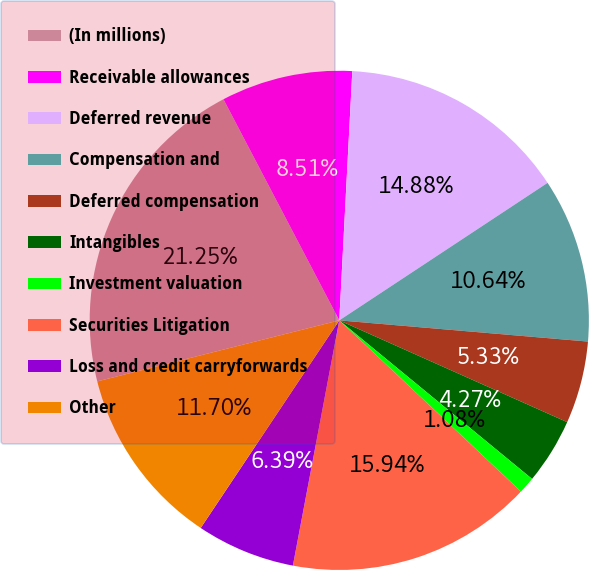Convert chart. <chart><loc_0><loc_0><loc_500><loc_500><pie_chart><fcel>(In millions)<fcel>Receivable allowances<fcel>Deferred revenue<fcel>Compensation and<fcel>Deferred compensation<fcel>Intangibles<fcel>Investment valuation<fcel>Securities Litigation<fcel>Loss and credit carryforwards<fcel>Other<nl><fcel>21.25%<fcel>8.51%<fcel>14.88%<fcel>10.64%<fcel>5.33%<fcel>4.27%<fcel>1.08%<fcel>15.94%<fcel>6.39%<fcel>11.7%<nl></chart> 